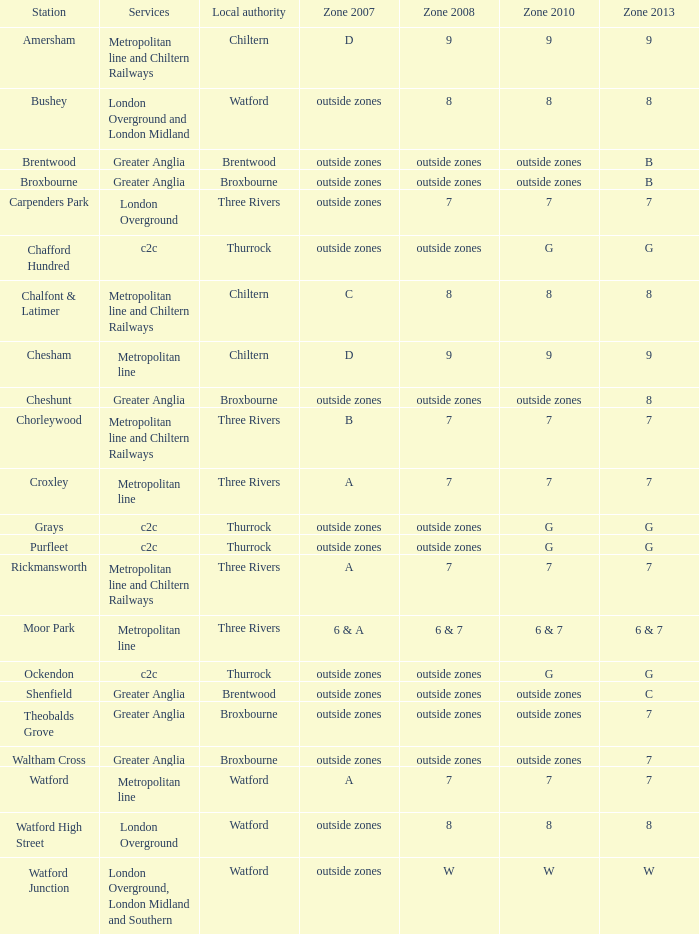Which station falls under zone 2010 category with the number 7? Carpenders Park, Chorleywood, Croxley, Rickmansworth, Watford. 